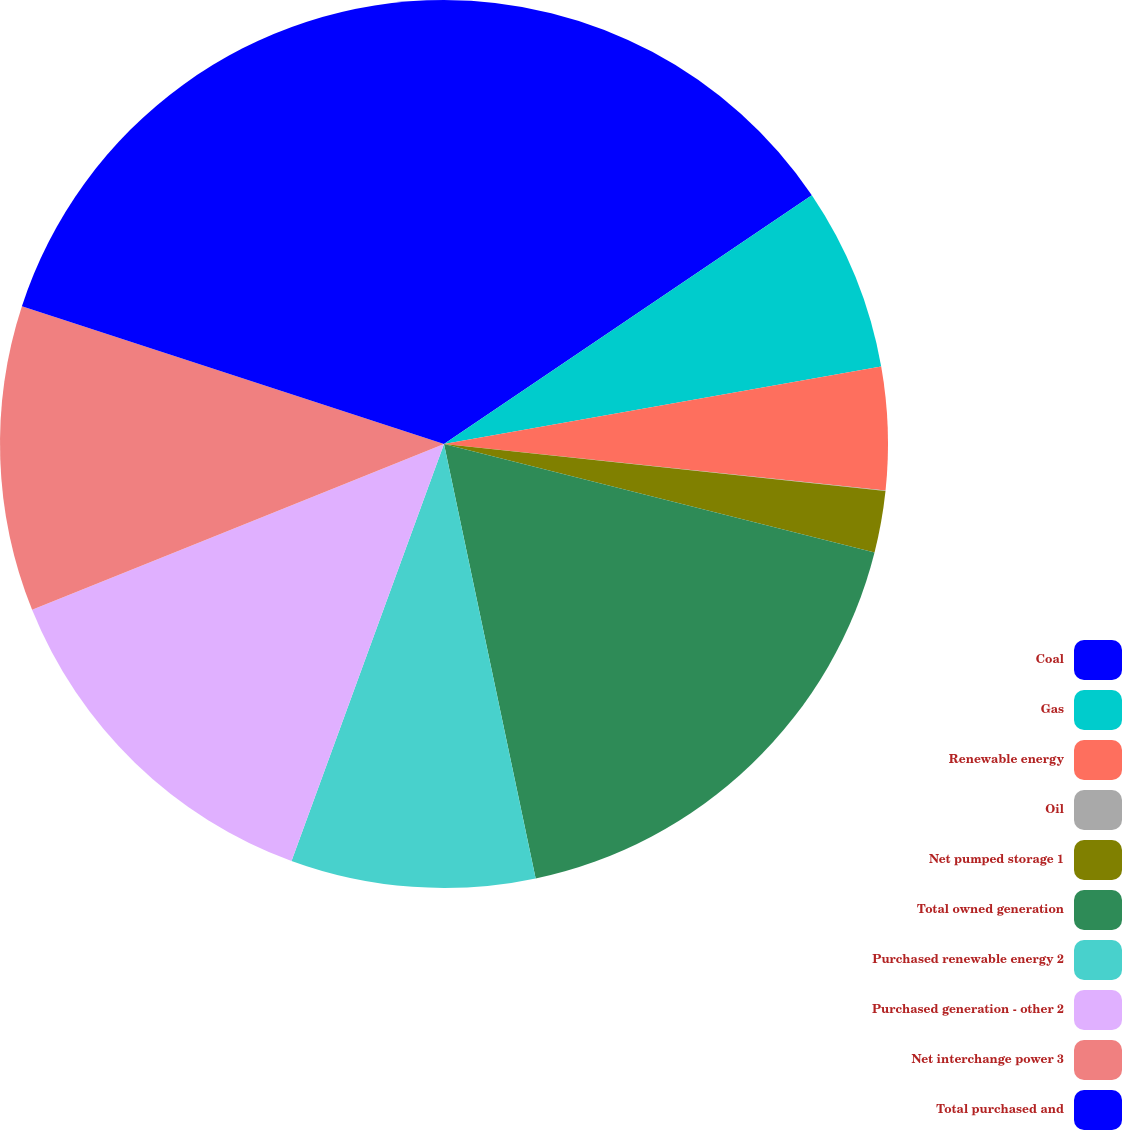Convert chart. <chart><loc_0><loc_0><loc_500><loc_500><pie_chart><fcel>Coal<fcel>Gas<fcel>Renewable energy<fcel>Oil<fcel>Net pumped storage 1<fcel>Total owned generation<fcel>Purchased renewable energy 2<fcel>Purchased generation - other 2<fcel>Net interchange power 3<fcel>Total purchased and<nl><fcel>15.54%<fcel>6.67%<fcel>4.46%<fcel>0.02%<fcel>2.24%<fcel>17.76%<fcel>8.89%<fcel>13.33%<fcel>11.11%<fcel>19.98%<nl></chart> 